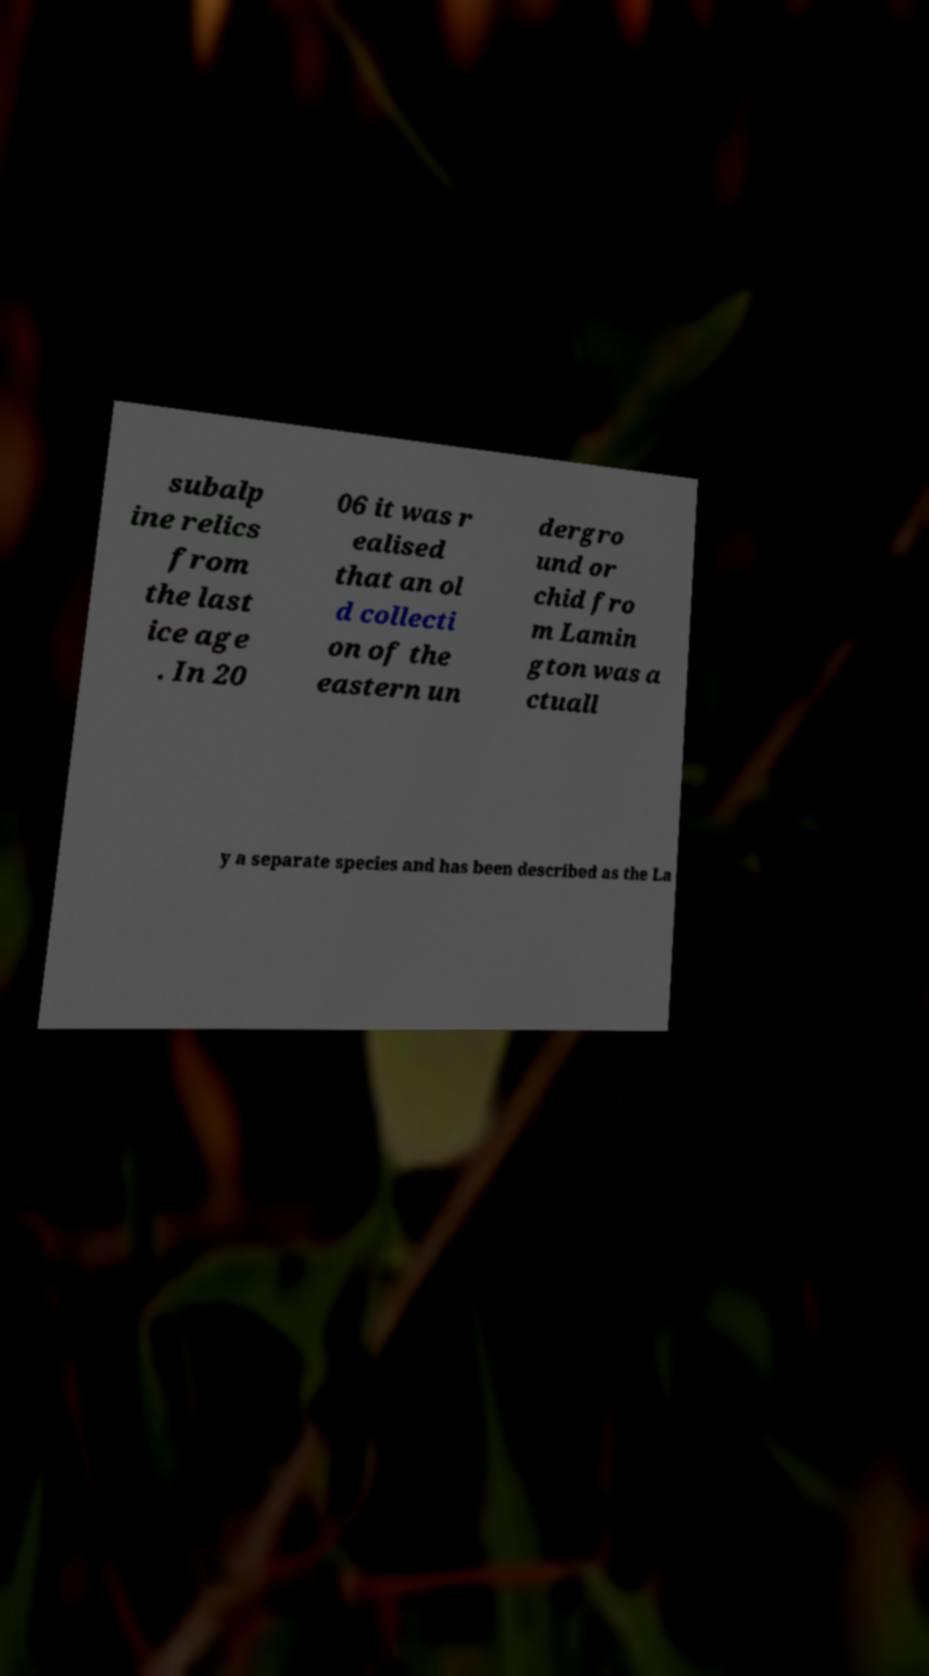Please identify and transcribe the text found in this image. subalp ine relics from the last ice age . In 20 06 it was r ealised that an ol d collecti on of the eastern un dergro und or chid fro m Lamin gton was a ctuall y a separate species and has been described as the La 